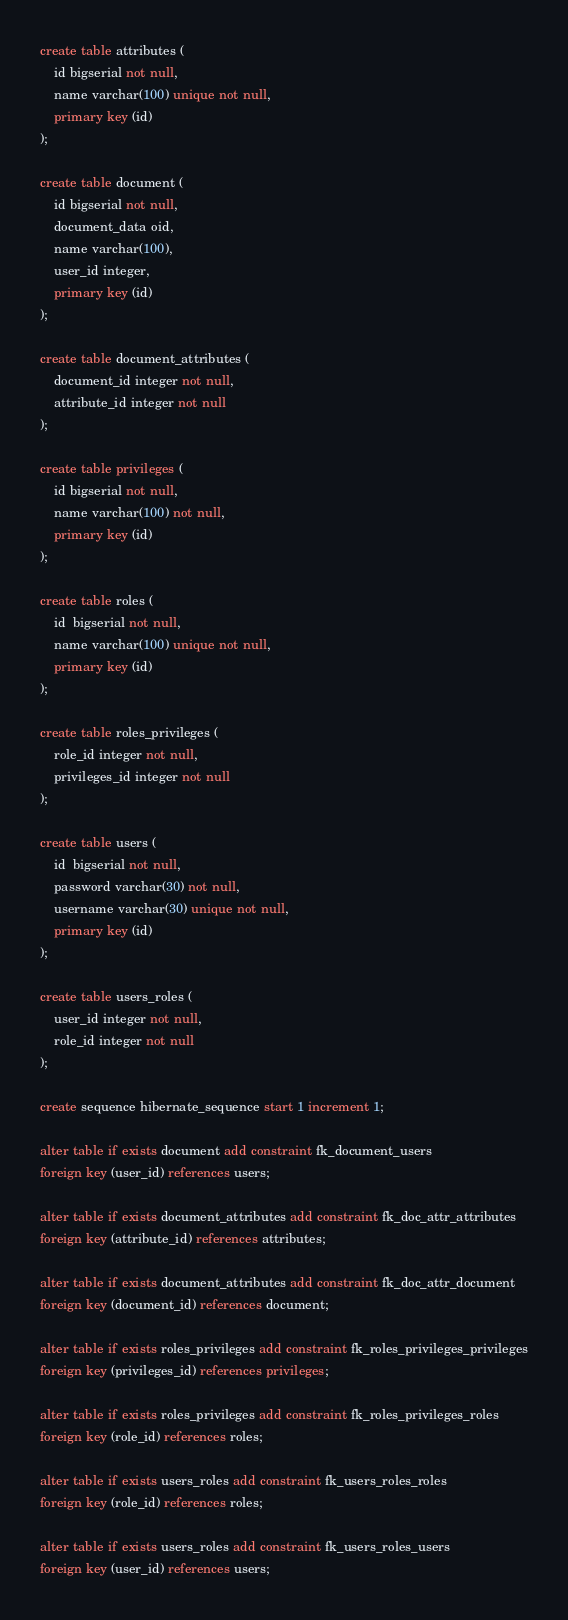<code> <loc_0><loc_0><loc_500><loc_500><_SQL_>create table attributes (
    id bigserial not null,
    name varchar(100) unique not null,
    primary key (id)
);

create table document (
    id bigserial not null,
    document_data oid,
    name varchar(100),
    user_id integer,
    primary key (id)
);

create table document_attributes (
    document_id integer not null,
    attribute_id integer not null
);

create table privileges (
    id bigserial not null,
    name varchar(100) not null,
    primary key (id)
);

create table roles (
    id  bigserial not null,
    name varchar(100) unique not null,
    primary key (id)
);

create table roles_privileges (
    role_id integer not null,
    privileges_id integer not null
);

create table users (
    id  bigserial not null,
    password varchar(30) not null,
    username varchar(30) unique not null,
    primary key (id)
);

create table users_roles (
    user_id integer not null,
    role_id integer not null
);

create sequence hibernate_sequence start 1 increment 1;

alter table if exists document add constraint fk_document_users
foreign key (user_id) references users;

alter table if exists document_attributes add constraint fk_doc_attr_attributes
foreign key (attribute_id) references attributes;

alter table if exists document_attributes add constraint fk_doc_attr_document
foreign key (document_id) references document;

alter table if exists roles_privileges add constraint fk_roles_privileges_privileges
foreign key (privileges_id) references privileges;

alter table if exists roles_privileges add constraint fk_roles_privileges_roles
foreign key (role_id) references roles;

alter table if exists users_roles add constraint fk_users_roles_roles
foreign key (role_id) references roles;

alter table if exists users_roles add constraint fk_users_roles_users
foreign key (user_id) references users;
</code> 